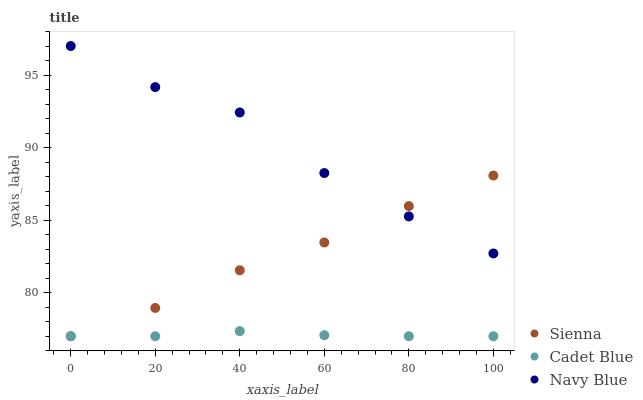Does Cadet Blue have the minimum area under the curve?
Answer yes or no. Yes. Does Navy Blue have the maximum area under the curve?
Answer yes or no. Yes. Does Navy Blue have the minimum area under the curve?
Answer yes or no. No. Does Cadet Blue have the maximum area under the curve?
Answer yes or no. No. Is Cadet Blue the smoothest?
Answer yes or no. Yes. Is Navy Blue the roughest?
Answer yes or no. Yes. Is Navy Blue the smoothest?
Answer yes or no. No. Is Cadet Blue the roughest?
Answer yes or no. No. Does Sienna have the lowest value?
Answer yes or no. Yes. Does Navy Blue have the lowest value?
Answer yes or no. No. Does Navy Blue have the highest value?
Answer yes or no. Yes. Does Cadet Blue have the highest value?
Answer yes or no. No. Is Cadet Blue less than Navy Blue?
Answer yes or no. Yes. Is Navy Blue greater than Cadet Blue?
Answer yes or no. Yes. Does Sienna intersect Navy Blue?
Answer yes or no. Yes. Is Sienna less than Navy Blue?
Answer yes or no. No. Is Sienna greater than Navy Blue?
Answer yes or no. No. Does Cadet Blue intersect Navy Blue?
Answer yes or no. No. 